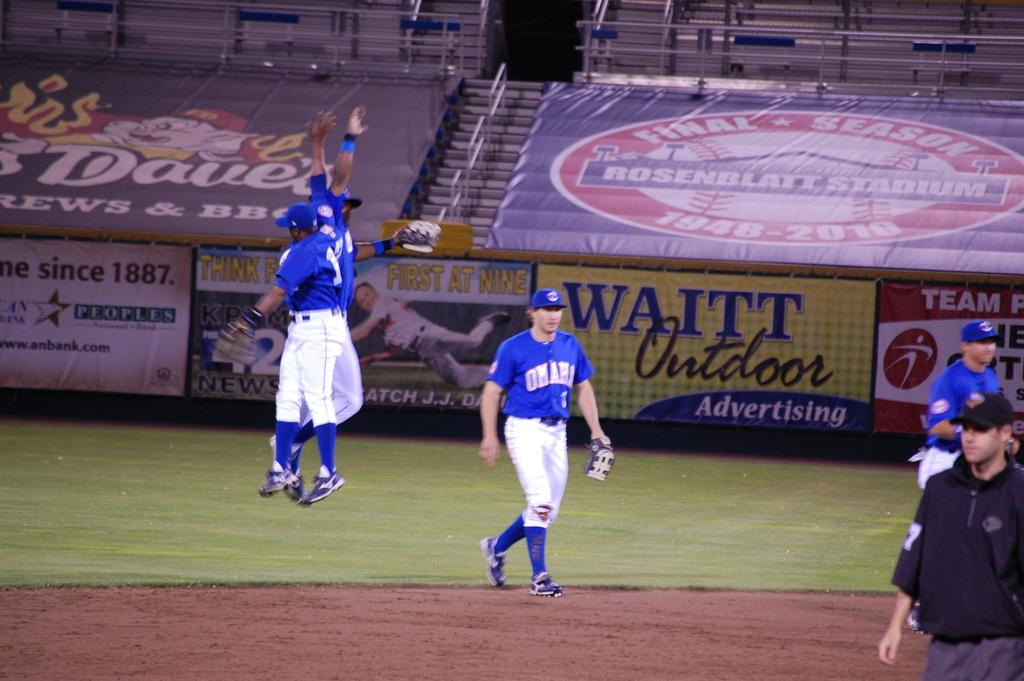Provide a one-sentence caption for the provided image. Baseball game with Waitt Outdoor Adverstising on the fence. 